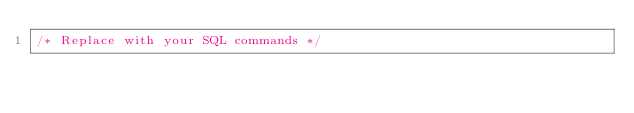<code> <loc_0><loc_0><loc_500><loc_500><_SQL_>/* Replace with your SQL commands */
</code> 